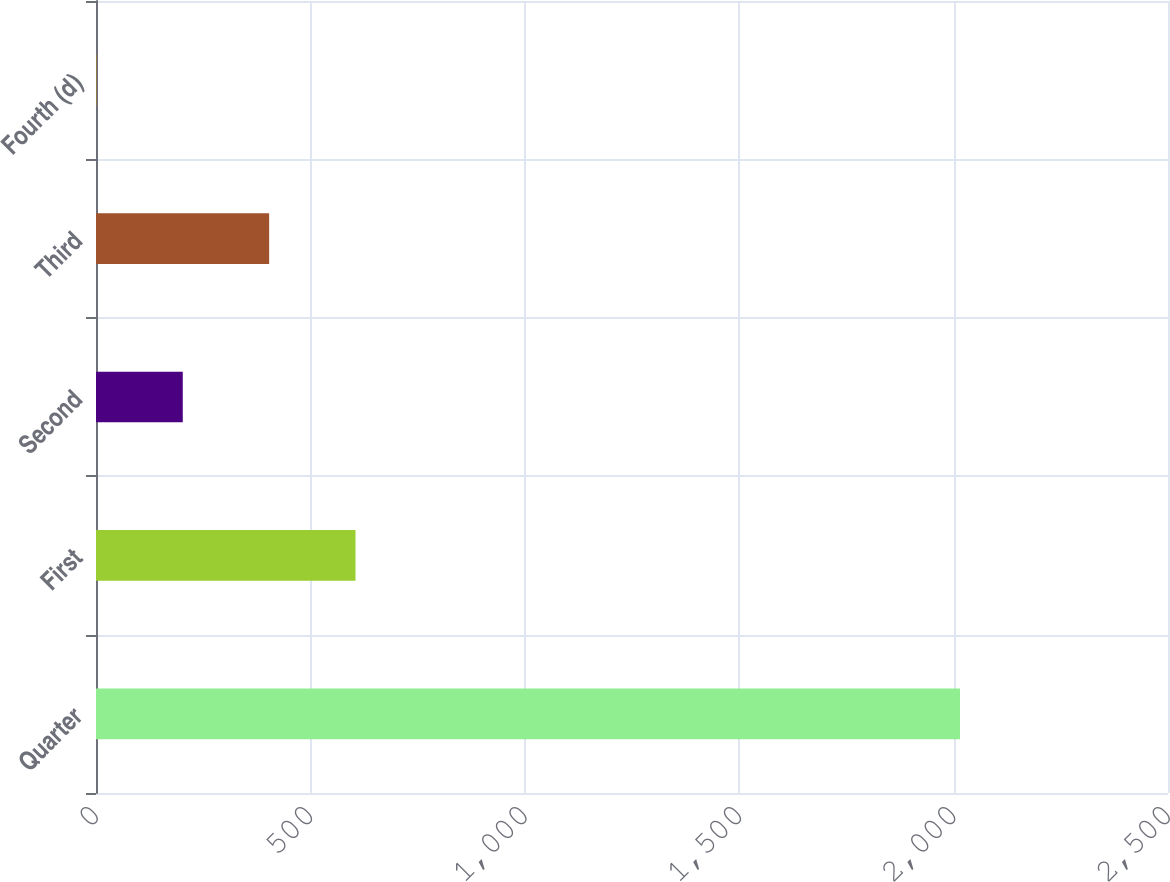Convert chart to OTSL. <chart><loc_0><loc_0><loc_500><loc_500><bar_chart><fcel>Quarter<fcel>First<fcel>Second<fcel>Third<fcel>Fourth (d)<nl><fcel>2015<fcel>605.18<fcel>202.38<fcel>403.78<fcel>0.98<nl></chart> 